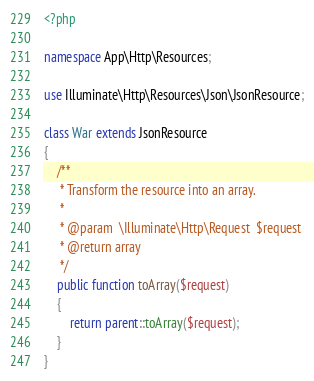<code> <loc_0><loc_0><loc_500><loc_500><_PHP_><?php

namespace App\Http\Resources;

use Illuminate\Http\Resources\Json\JsonResource;

class War extends JsonResource
{
    /**
     * Transform the resource into an array.
     *
     * @param  \Illuminate\Http\Request  $request
     * @return array
     */
    public function toArray($request)
    {
        return parent::toArray($request);
    }
}
</code> 